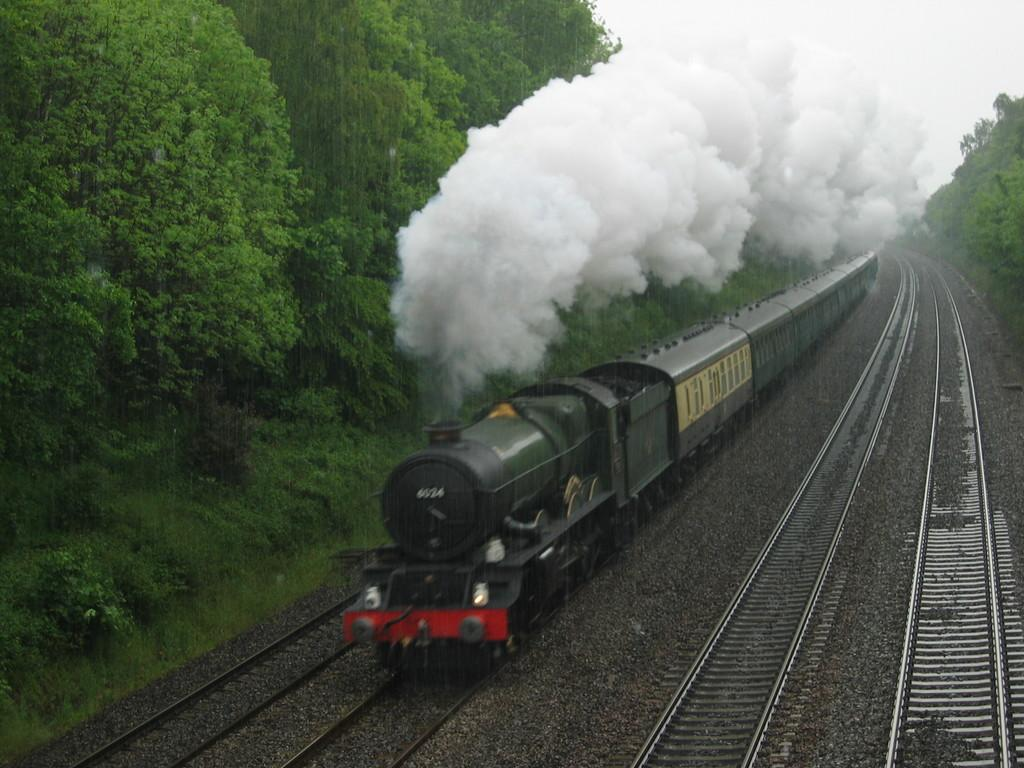What is the main subject of the image? The main subject of the image is a train. Where is the train located in the image? The train is on a train track. What type of terrain can be seen in the image? There are stones, grass, and trees visible in the image. What is the train emitting in the image? Smoke is visible in the image. What part of the natural environment is visible in the image? The sky is visible in the image. What type of fruit is hanging from the trees in the image? There is no fruit visible in the image; only trees are present. What is the train's temper like in the image? The train is an inanimate object and does not have a temper. 